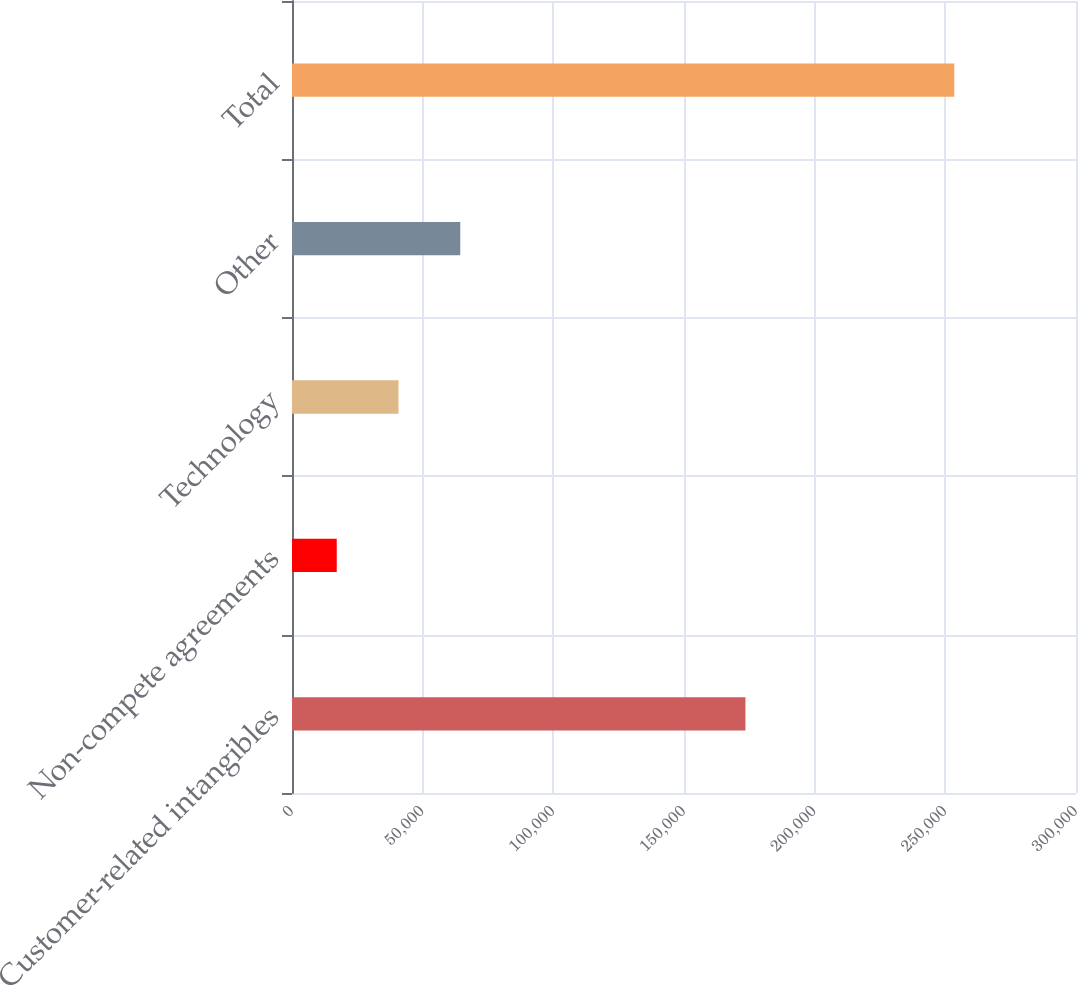Convert chart to OTSL. <chart><loc_0><loc_0><loc_500><loc_500><bar_chart><fcel>Customer-related intangibles<fcel>Non-compete agreements<fcel>Technology<fcel>Other<fcel>Total<nl><fcel>173516<fcel>17123<fcel>40752.4<fcel>64381.8<fcel>253417<nl></chart> 